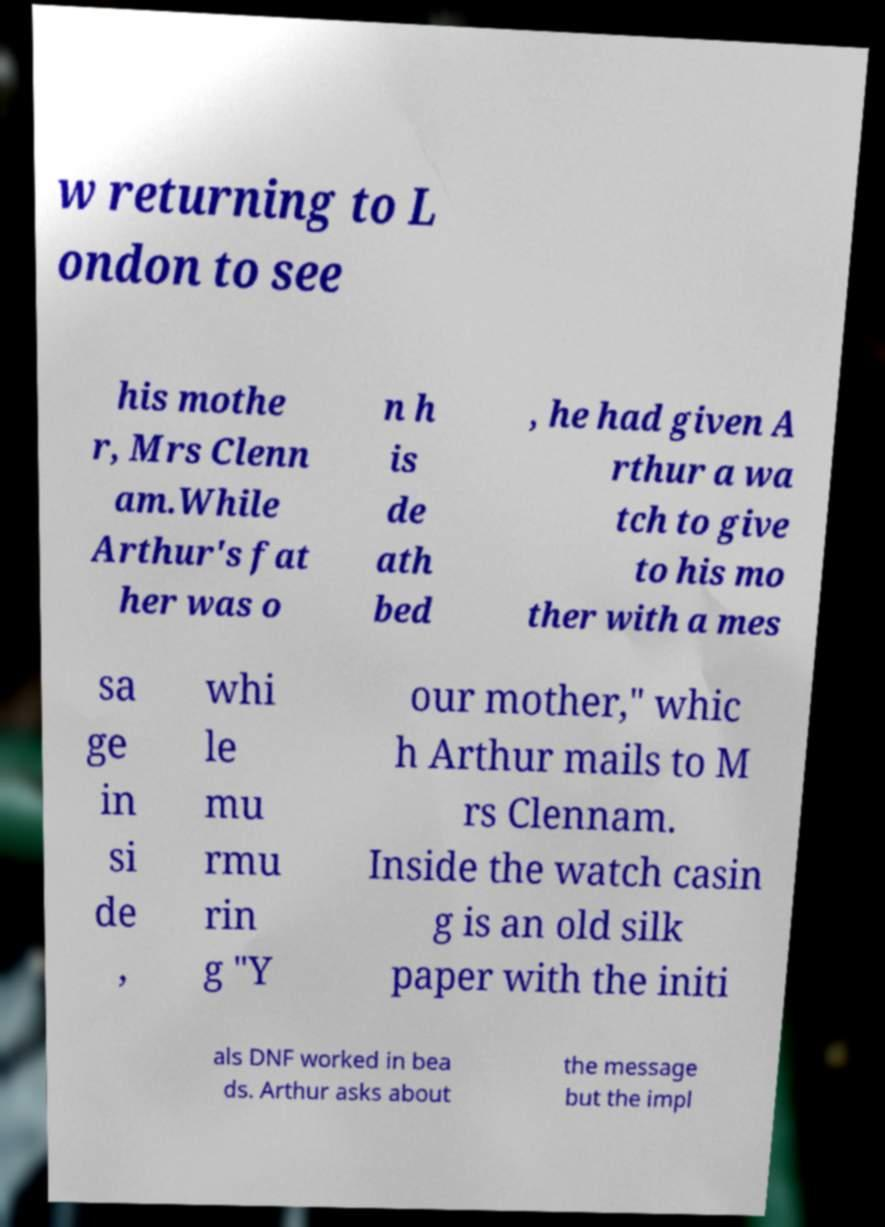What messages or text are displayed in this image? I need them in a readable, typed format. w returning to L ondon to see his mothe r, Mrs Clenn am.While Arthur's fat her was o n h is de ath bed , he had given A rthur a wa tch to give to his mo ther with a mes sa ge in si de , whi le mu rmu rin g "Y our mother," whic h Arthur mails to M rs Clennam. Inside the watch casin g is an old silk paper with the initi als DNF worked in bea ds. Arthur asks about the message but the impl 